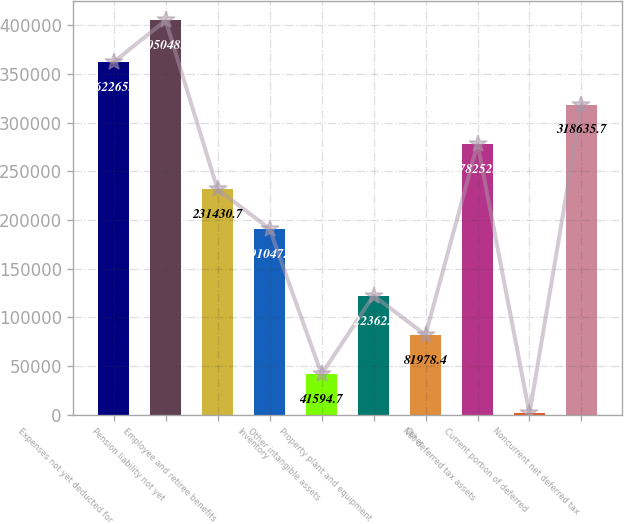Convert chart. <chart><loc_0><loc_0><loc_500><loc_500><bar_chart><fcel>Expenses not yet deducted for<fcel>Pension liability not yet<fcel>Employee and retiree benefits<fcel>Inventory<fcel>Other intangible assets<fcel>Property plant and equipment<fcel>Other<fcel>Net deferred tax assets<fcel>Current portion of deferred<fcel>Noncurrent net deferred tax<nl><fcel>362265<fcel>405048<fcel>231431<fcel>191047<fcel>41594.7<fcel>122362<fcel>81978.4<fcel>278252<fcel>1211<fcel>318636<nl></chart> 